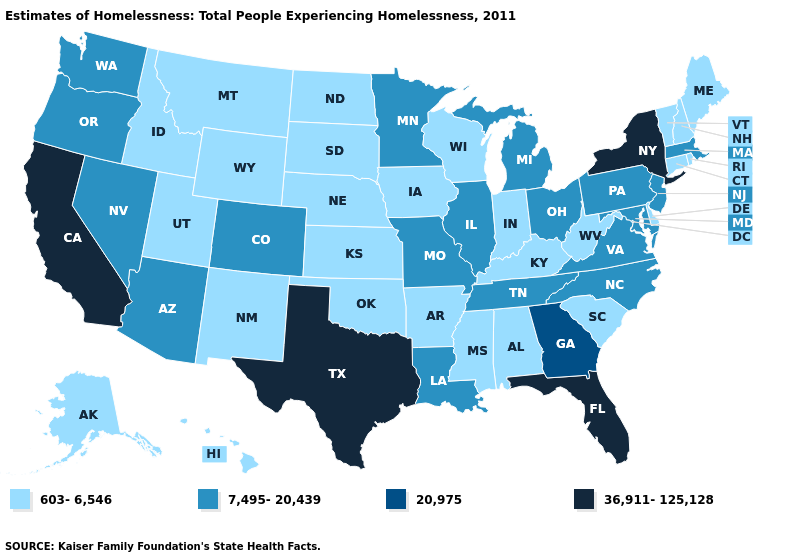What is the value of Indiana?
Quick response, please. 603-6,546. Among the states that border California , which have the lowest value?
Keep it brief. Arizona, Nevada, Oregon. Among the states that border New York , does Connecticut have the lowest value?
Keep it brief. Yes. What is the value of Rhode Island?
Quick response, please. 603-6,546. Name the states that have a value in the range 7,495-20,439?
Short answer required. Arizona, Colorado, Illinois, Louisiana, Maryland, Massachusetts, Michigan, Minnesota, Missouri, Nevada, New Jersey, North Carolina, Ohio, Oregon, Pennsylvania, Tennessee, Virginia, Washington. Among the states that border Washington , which have the highest value?
Quick response, please. Oregon. Does New York have the highest value in the Northeast?
Concise answer only. Yes. Is the legend a continuous bar?
Quick response, please. No. Does South Carolina have the lowest value in the USA?
Answer briefly. Yes. Does the first symbol in the legend represent the smallest category?
Answer briefly. Yes. What is the value of South Dakota?
Answer briefly. 603-6,546. What is the lowest value in the USA?
Short answer required. 603-6,546. Name the states that have a value in the range 7,495-20,439?
Short answer required. Arizona, Colorado, Illinois, Louisiana, Maryland, Massachusetts, Michigan, Minnesota, Missouri, Nevada, New Jersey, North Carolina, Ohio, Oregon, Pennsylvania, Tennessee, Virginia, Washington. Name the states that have a value in the range 36,911-125,128?
Give a very brief answer. California, Florida, New York, Texas. 